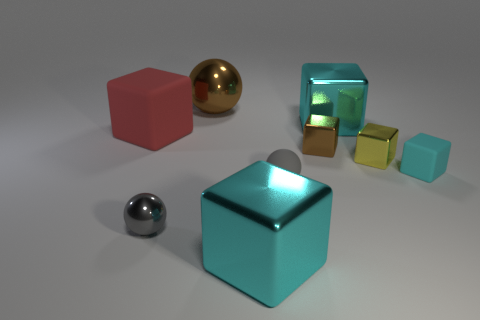What is the material of the small yellow object that is the same shape as the red object?
Your answer should be compact. Metal. The big sphere is what color?
Ensure brevity in your answer.  Brown. Is the color of the small metallic sphere the same as the small matte ball?
Your answer should be very brief. Yes. How many small gray rubber spheres are behind the matte cube behind the tiny cyan block?
Your answer should be very brief. 0. How big is the shiny cube that is both in front of the tiny brown block and behind the small cyan matte cube?
Your response must be concise. Small. What is the cyan object left of the small brown shiny block made of?
Give a very brief answer. Metal. Are there any yellow metallic objects of the same shape as the large brown shiny object?
Give a very brief answer. No. How many other objects have the same shape as the small gray metallic object?
Offer a very short reply. 2. Do the brown metal block that is in front of the large matte thing and the cyan metal block that is in front of the yellow thing have the same size?
Your answer should be very brief. No. The gray metal object that is in front of the matte thing on the left side of the brown metal sphere is what shape?
Offer a terse response. Sphere. 